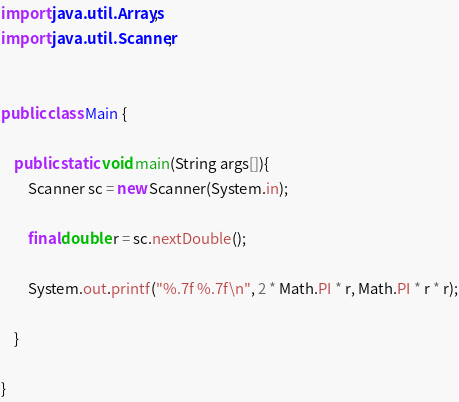Convert code to text. <code><loc_0><loc_0><loc_500><loc_500><_Java_>import java.util.Arrays;
import java.util.Scanner;


public class Main {
	
	public static void main(String args[]){
		Scanner sc = new Scanner(System.in);
		
		final double r = sc.nextDouble();
		
		System.out.printf("%.7f %.7f\n", 2 * Math.PI * r, Math.PI * r * r);
		
	}
	
}</code> 